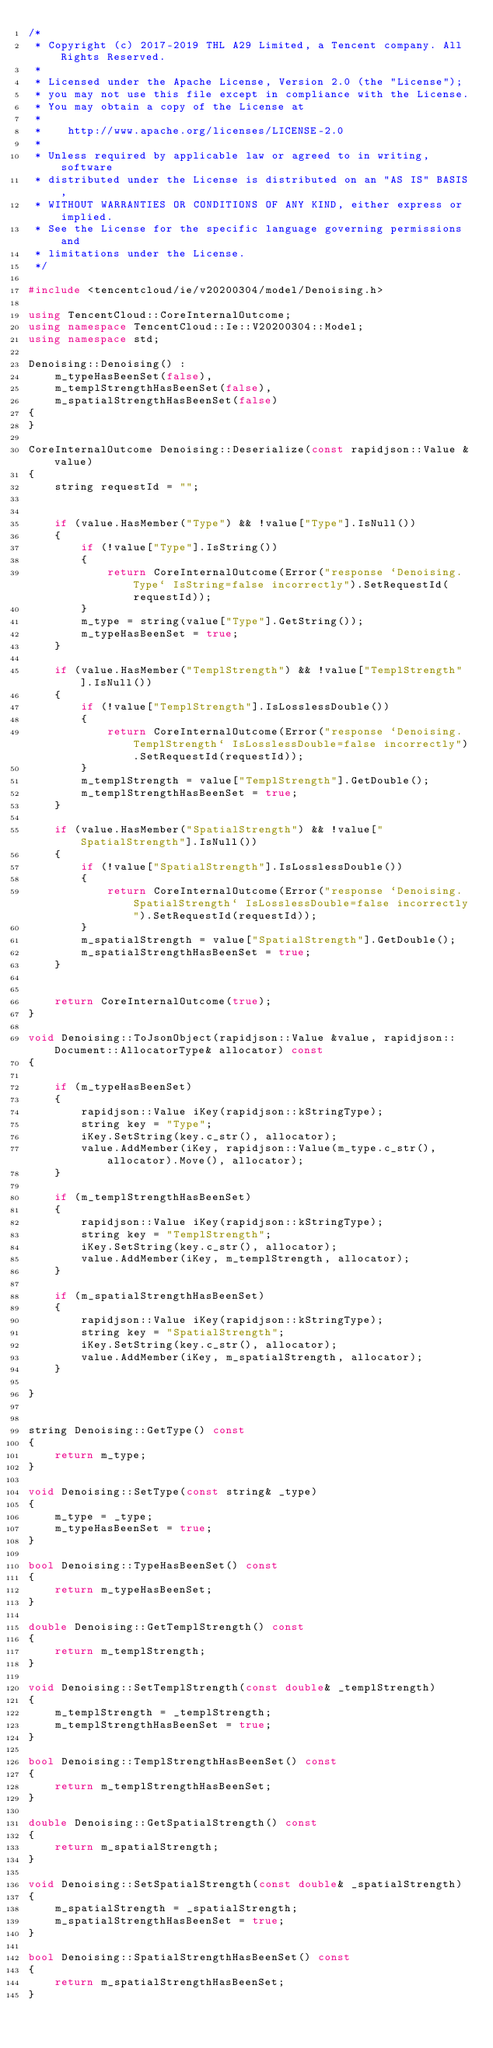Convert code to text. <code><loc_0><loc_0><loc_500><loc_500><_C++_>/*
 * Copyright (c) 2017-2019 THL A29 Limited, a Tencent company. All Rights Reserved.
 *
 * Licensed under the Apache License, Version 2.0 (the "License");
 * you may not use this file except in compliance with the License.
 * You may obtain a copy of the License at
 *
 *    http://www.apache.org/licenses/LICENSE-2.0
 *
 * Unless required by applicable law or agreed to in writing, software
 * distributed under the License is distributed on an "AS IS" BASIS,
 * WITHOUT WARRANTIES OR CONDITIONS OF ANY KIND, either express or implied.
 * See the License for the specific language governing permissions and
 * limitations under the License.
 */

#include <tencentcloud/ie/v20200304/model/Denoising.h>

using TencentCloud::CoreInternalOutcome;
using namespace TencentCloud::Ie::V20200304::Model;
using namespace std;

Denoising::Denoising() :
    m_typeHasBeenSet(false),
    m_templStrengthHasBeenSet(false),
    m_spatialStrengthHasBeenSet(false)
{
}

CoreInternalOutcome Denoising::Deserialize(const rapidjson::Value &value)
{
    string requestId = "";


    if (value.HasMember("Type") && !value["Type"].IsNull())
    {
        if (!value["Type"].IsString())
        {
            return CoreInternalOutcome(Error("response `Denoising.Type` IsString=false incorrectly").SetRequestId(requestId));
        }
        m_type = string(value["Type"].GetString());
        m_typeHasBeenSet = true;
    }

    if (value.HasMember("TemplStrength") && !value["TemplStrength"].IsNull())
    {
        if (!value["TemplStrength"].IsLosslessDouble())
        {
            return CoreInternalOutcome(Error("response `Denoising.TemplStrength` IsLosslessDouble=false incorrectly").SetRequestId(requestId));
        }
        m_templStrength = value["TemplStrength"].GetDouble();
        m_templStrengthHasBeenSet = true;
    }

    if (value.HasMember("SpatialStrength") && !value["SpatialStrength"].IsNull())
    {
        if (!value["SpatialStrength"].IsLosslessDouble())
        {
            return CoreInternalOutcome(Error("response `Denoising.SpatialStrength` IsLosslessDouble=false incorrectly").SetRequestId(requestId));
        }
        m_spatialStrength = value["SpatialStrength"].GetDouble();
        m_spatialStrengthHasBeenSet = true;
    }


    return CoreInternalOutcome(true);
}

void Denoising::ToJsonObject(rapidjson::Value &value, rapidjson::Document::AllocatorType& allocator) const
{

    if (m_typeHasBeenSet)
    {
        rapidjson::Value iKey(rapidjson::kStringType);
        string key = "Type";
        iKey.SetString(key.c_str(), allocator);
        value.AddMember(iKey, rapidjson::Value(m_type.c_str(), allocator).Move(), allocator);
    }

    if (m_templStrengthHasBeenSet)
    {
        rapidjson::Value iKey(rapidjson::kStringType);
        string key = "TemplStrength";
        iKey.SetString(key.c_str(), allocator);
        value.AddMember(iKey, m_templStrength, allocator);
    }

    if (m_spatialStrengthHasBeenSet)
    {
        rapidjson::Value iKey(rapidjson::kStringType);
        string key = "SpatialStrength";
        iKey.SetString(key.c_str(), allocator);
        value.AddMember(iKey, m_spatialStrength, allocator);
    }

}


string Denoising::GetType() const
{
    return m_type;
}

void Denoising::SetType(const string& _type)
{
    m_type = _type;
    m_typeHasBeenSet = true;
}

bool Denoising::TypeHasBeenSet() const
{
    return m_typeHasBeenSet;
}

double Denoising::GetTemplStrength() const
{
    return m_templStrength;
}

void Denoising::SetTemplStrength(const double& _templStrength)
{
    m_templStrength = _templStrength;
    m_templStrengthHasBeenSet = true;
}

bool Denoising::TemplStrengthHasBeenSet() const
{
    return m_templStrengthHasBeenSet;
}

double Denoising::GetSpatialStrength() const
{
    return m_spatialStrength;
}

void Denoising::SetSpatialStrength(const double& _spatialStrength)
{
    m_spatialStrength = _spatialStrength;
    m_spatialStrengthHasBeenSet = true;
}

bool Denoising::SpatialStrengthHasBeenSet() const
{
    return m_spatialStrengthHasBeenSet;
}

</code> 